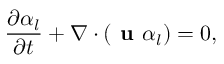<formula> <loc_0><loc_0><loc_500><loc_500>\frac { \partial { \alpha _ { l } } } { \partial { t } } + \nabla \cdot ( u \alpha _ { l } ) = 0 ,</formula> 